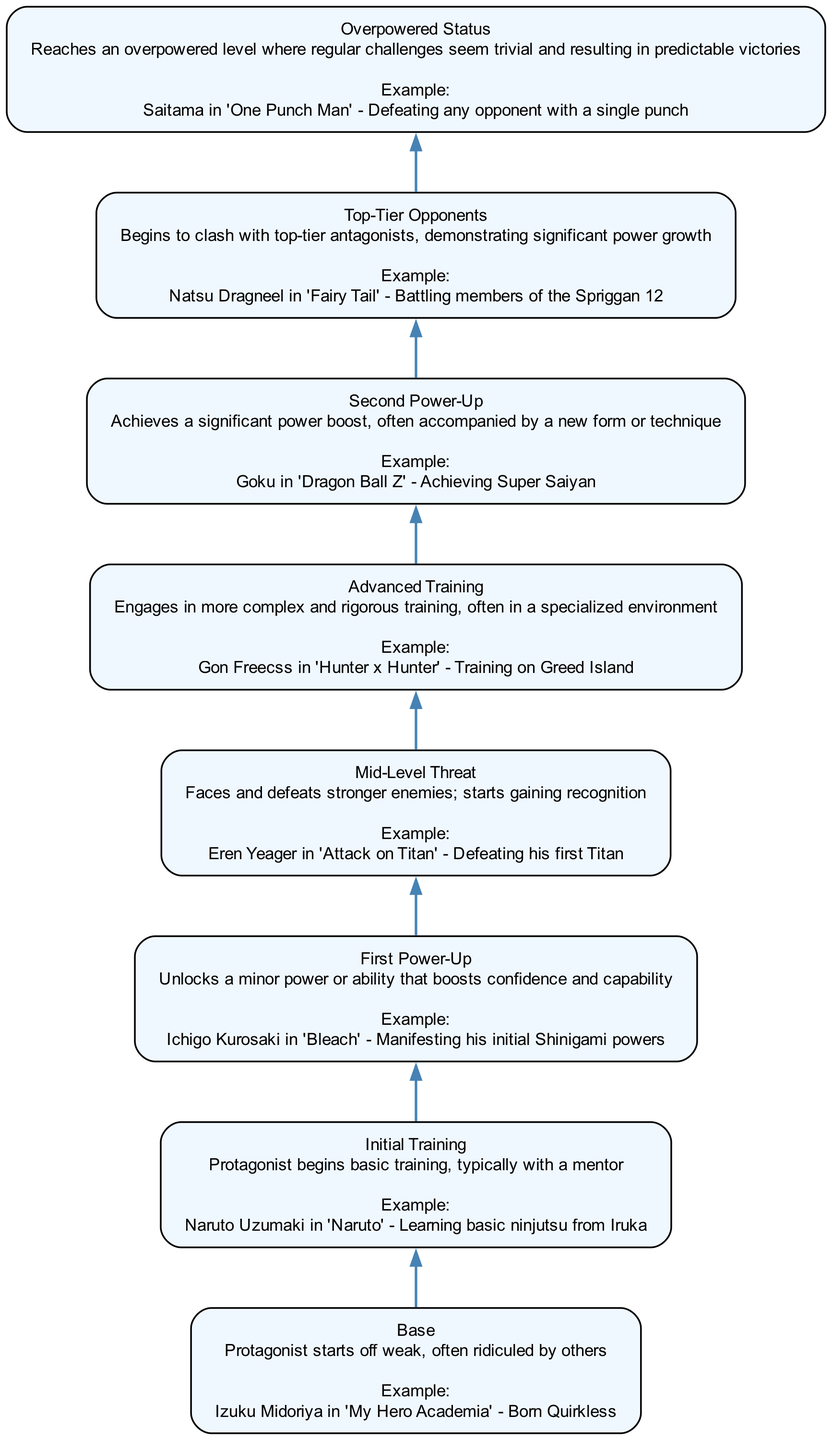What is the highest power level represented in the diagram? The diagram illustrates an evolution of power levels, with the highest level being "Overpowered Status" at the top of the flow chart.
Answer: Overpowered Status Which protagonist is associated with the "First Power-Up" level? According to the diagram, "Ichigo Kurosaki in 'Bleach'" is listed as the example under the "First Power-Up" level.
Answer: Ichigo Kurosaki How many levels are there in the diagram? The diagram contains eight distinct levels, starting from "Base" and ending with "Overpowered Status."
Answer: Eight What does the "Mid-Level Threat" level represent? The "Mid-Level Threat" level indicates that the protagonist is beginning to gain recognition by defeating stronger enemies, as represented by the example of "Eren Yeager in 'Attack on Titan'."
Answer: Faces and defeats stronger enemies Which level comes immediately before "Second Power-Up"? Referring to the flow of the diagram, "Advanced Training" is the level that directly proceeds "Second Power-Up."
Answer: Advanced Training What description is associated with the "Top-Tier Opponents" level? The description for the "Top-Tier Opponents" level mentions that protagonists clash with top-tier antagonists, as shown in the example "Natsu Dragneel in 'Fairy Tail'."
Answer: Begins to clash with top-tier antagonists Who achieves a significant power boost in the "Second Power-Up" level? The diagram states that "Goku in 'Dragon Ball Z'" is the protagonist that achieves a significant power boost at the "Second Power-Up" level.
Answer: Goku What is a common theme found throughout the levels in the diagram? The common theme across all levels in the diagram is that each step signifies a progressive increase in strength and capability for the protagonist.
Answer: Progressive increase in strength At which level does the protagonist typically start their journey? The journey begins at the "Base" level, where the protagonist is characterized as weak and often ridiculed.
Answer: Base 